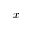<formula> <loc_0><loc_0><loc_500><loc_500>x</formula> 